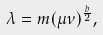Convert formula to latex. <formula><loc_0><loc_0><loc_500><loc_500>\lambda = m ( \mu \nu ) ^ { \frac { b } { 2 } } ,</formula> 